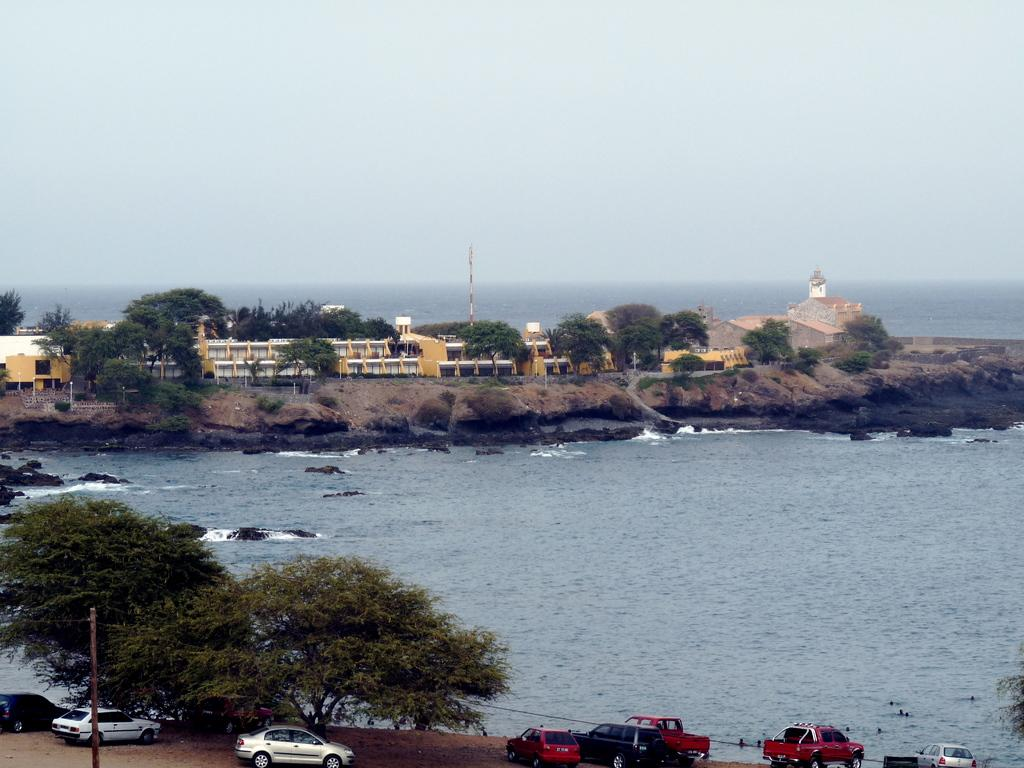What is the primary element visible in the image? There is water in the image. What type of natural elements can be seen in the image? There are trees in the image. What type of man-made structures are present in the image? There are buildings in the image. What type of transportation is visible in the image? There are vehicles in the image. What object is standing upright in the image? There is a pole in the image. What type of skin can be seen on the surface of the water in the image? There is no skin visible in the image; it is water. What type of milk is being produced by the trees in the image? There are no trees producing milk in the image; trees do not produce milk. 